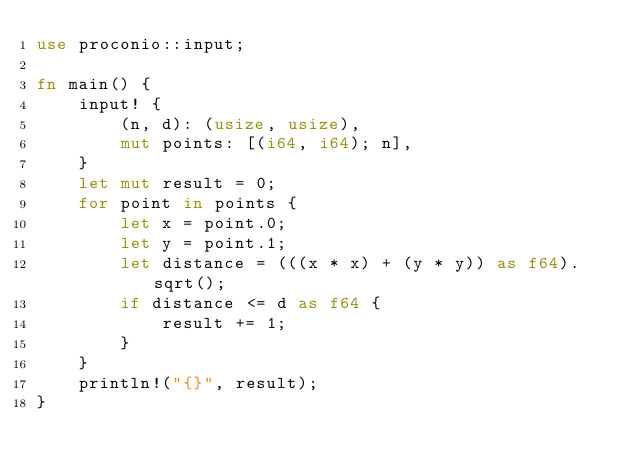<code> <loc_0><loc_0><loc_500><loc_500><_Rust_>use proconio::input;

fn main() {
    input! {
        (n, d): (usize, usize),
        mut points: [(i64, i64); n],
    }
    let mut result = 0;
    for point in points {
        let x = point.0;
        let y = point.1;
        let distance = (((x * x) + (y * y)) as f64).sqrt();
        if distance <= d as f64 {
            result += 1;
        }
    }
    println!("{}", result);
}
</code> 